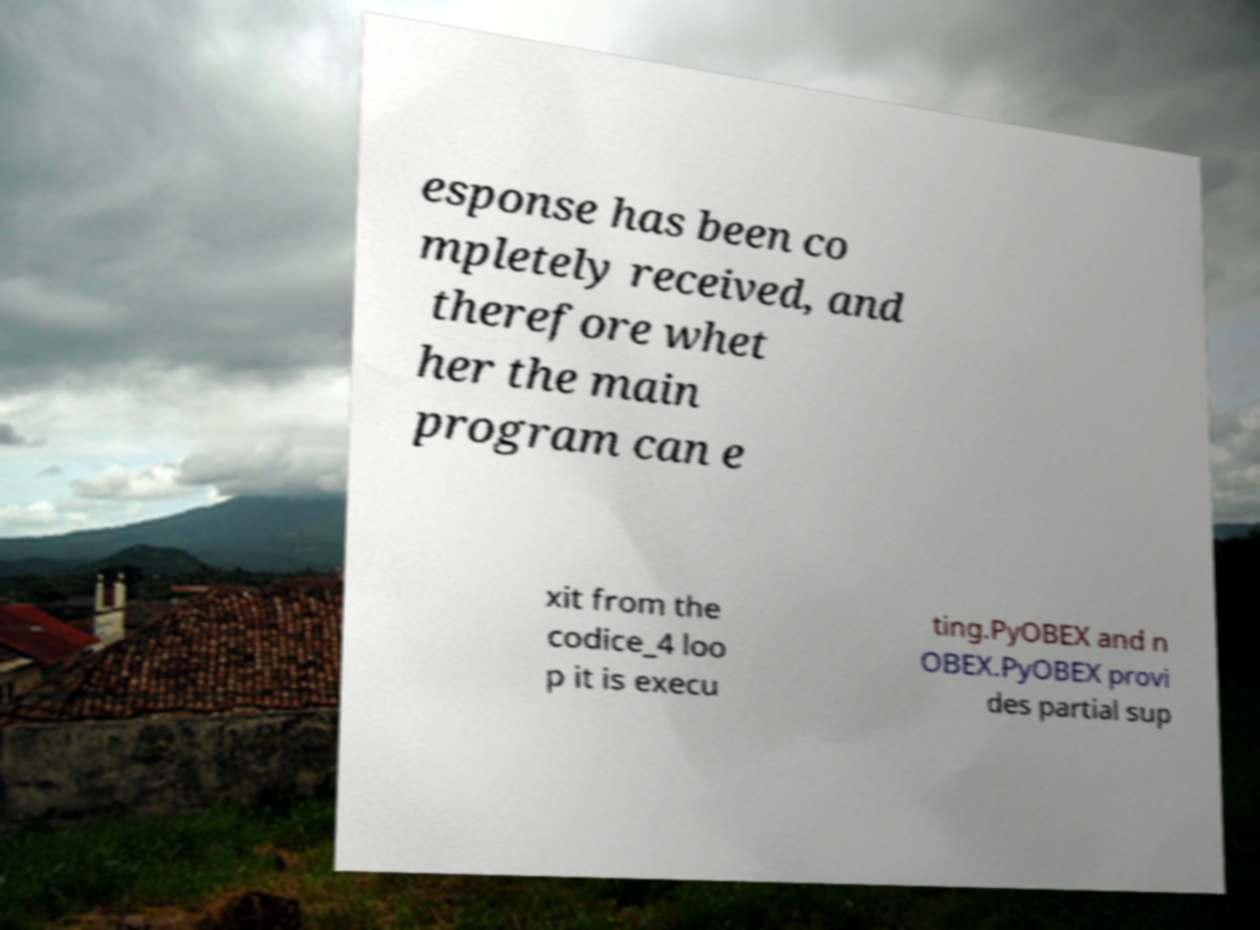Could you extract and type out the text from this image? esponse has been co mpletely received, and therefore whet her the main program can e xit from the codice_4 loo p it is execu ting.PyOBEX and n OBEX.PyOBEX provi des partial sup 